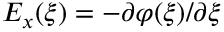<formula> <loc_0><loc_0><loc_500><loc_500>E _ { x } ( \xi ) = - \partial \varphi ( \xi ) / \partial \xi</formula> 